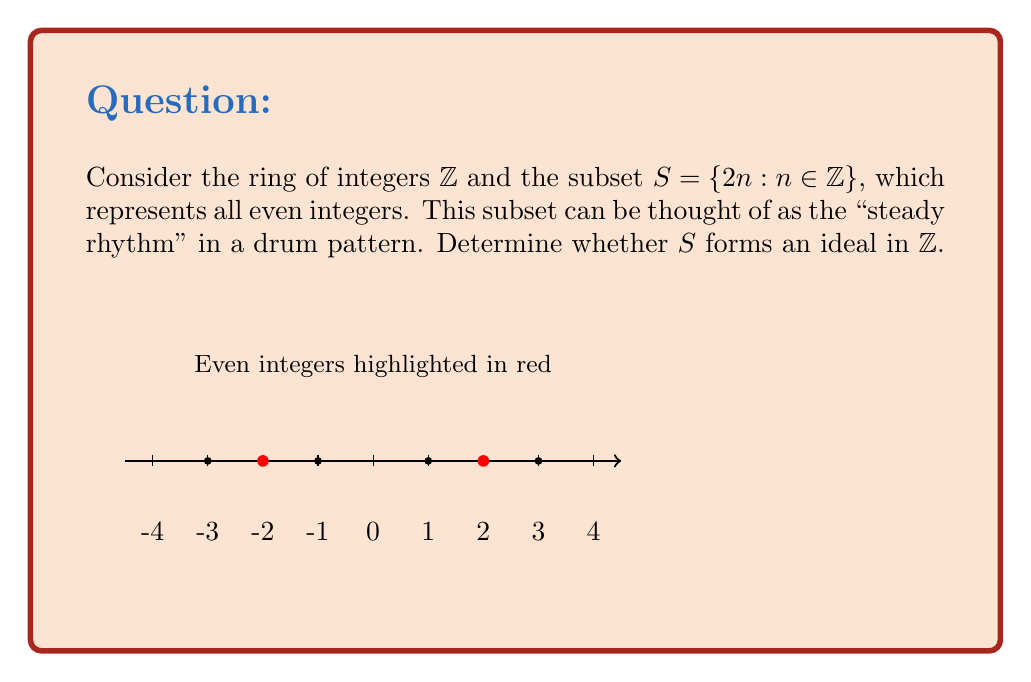Solve this math problem. To determine whether $S$ forms an ideal in $\mathbb{Z}$, we need to check if it satisfies the two properties of an ideal:

1. Closure under addition: For any $a, b \in S$, $a + b \in S$
2. Absorption of ring multiplication: For any $r \in \mathbb{Z}$ and $s \in S$, $rs \in S$

Let's check each property:

1. Closure under addition:
   Let $a, b \in S$. Then $a = 2m$ and $b = 2n$ for some $m, n \in \mathbb{Z}$.
   $a + b = 2m + 2n = 2(m + n)$
   Since $m + n \in \mathbb{Z}$, $2(m + n) \in S$. Thus, $S$ is closed under addition.

2. Absorption of ring multiplication:
   Let $r \in \mathbb{Z}$ and $s \in S$. Then $s = 2n$ for some $n \in \mathbb{Z}$.
   $rs = r(2n) = 2(rn)$
   Since $rn \in \mathbb{Z}$, $2(rn) \in S$. Thus, $S$ absorbs multiplication by elements of $\mathbb{Z}$.

Since $S$ satisfies both properties, it forms an ideal in $\mathbb{Z}$. This ideal is commonly known as the even integer ideal.
Answer: Yes, $S$ forms an ideal in $\mathbb{Z}$. 